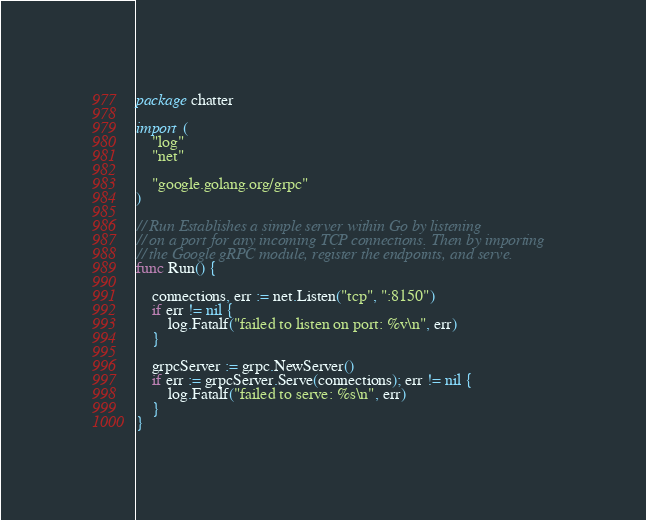<code> <loc_0><loc_0><loc_500><loc_500><_Go_>package chatter

import (
	"log"
	"net"

	"google.golang.org/grpc"
)

// Run Establishes a simple server within Go by listening
// on a port for any incoming TCP connections. Then by importing
// the Google gRPC module, register the endpoints, and serve.
func Run() {

	connections, err := net.Listen("tcp", ":8150")
	if err != nil {
		log.Fatalf("failed to listen on port: %v\n", err)
	}

	grpcServer := grpc.NewServer()
	if err := grpcServer.Serve(connections); err != nil {
		log.Fatalf("failed to serve: %s\n", err)
	}
}

</code> 